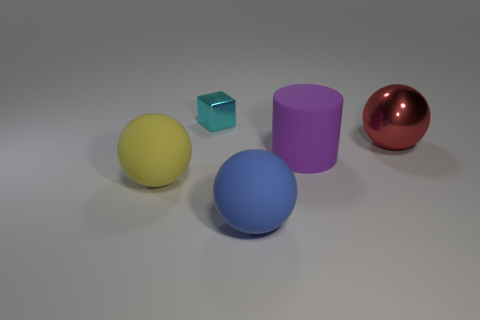Add 3 red spheres. How many objects exist? 8 Subtract all spheres. How many objects are left? 2 Add 1 tiny purple matte blocks. How many tiny purple matte blocks exist? 1 Subtract 0 green cylinders. How many objects are left? 5 Subtract all big metallic cylinders. Subtract all cyan cubes. How many objects are left? 4 Add 5 large blue matte objects. How many large blue matte objects are left? 6 